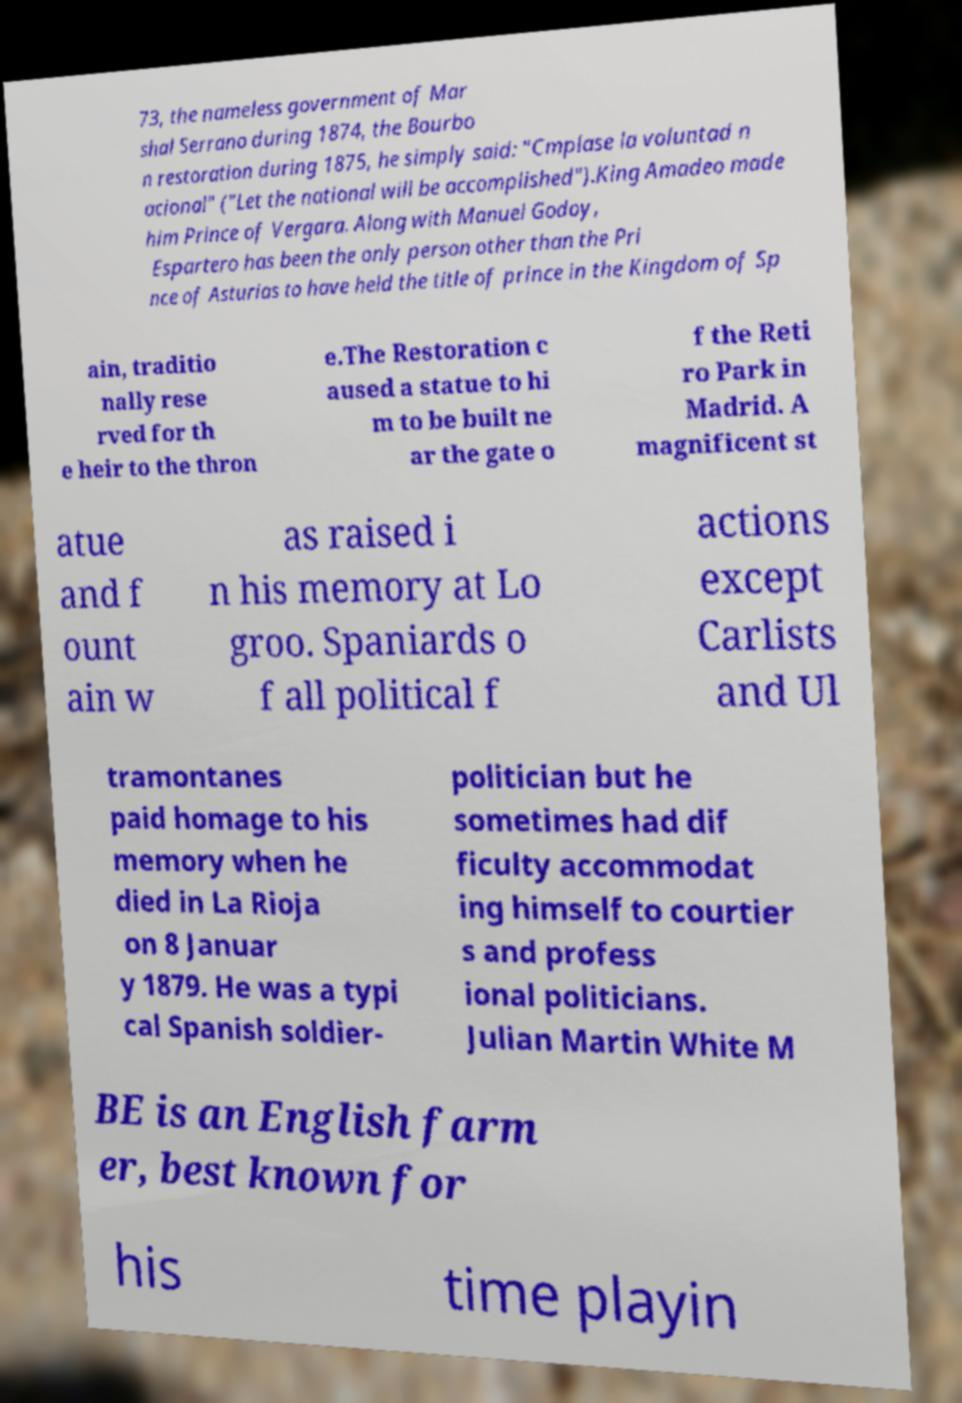Could you assist in decoding the text presented in this image and type it out clearly? 73, the nameless government of Mar shal Serrano during 1874, the Bourbo n restoration during 1875, he simply said: "Cmplase la voluntad n acional" ("Let the national will be accomplished").King Amadeo made him Prince of Vergara. Along with Manuel Godoy, Espartero has been the only person other than the Pri nce of Asturias to have held the title of prince in the Kingdom of Sp ain, traditio nally rese rved for th e heir to the thron e.The Restoration c aused a statue to hi m to be built ne ar the gate o f the Reti ro Park in Madrid. A magnificent st atue and f ount ain w as raised i n his memory at Lo groo. Spaniards o f all political f actions except Carlists and Ul tramontanes paid homage to his memory when he died in La Rioja on 8 Januar y 1879. He was a typi cal Spanish soldier- politician but he sometimes had dif ficulty accommodat ing himself to courtier s and profess ional politicians. Julian Martin White M BE is an English farm er, best known for his time playin 